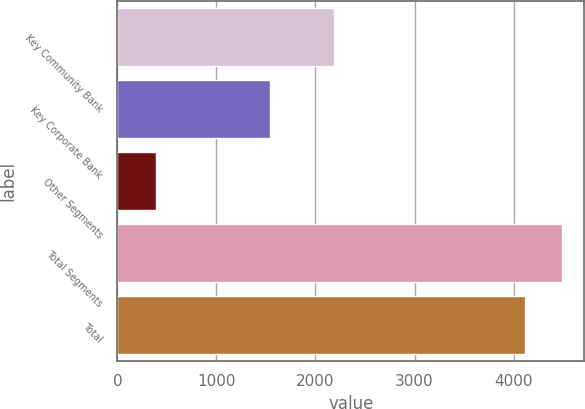Convert chart to OTSL. <chart><loc_0><loc_0><loc_500><loc_500><bar_chart><fcel>Key Community Bank<fcel>Key Corporate Bank<fcel>Other Segments<fcel>Total Segments<fcel>Total<nl><fcel>2191<fcel>1538<fcel>387<fcel>4486.9<fcel>4114<nl></chart> 